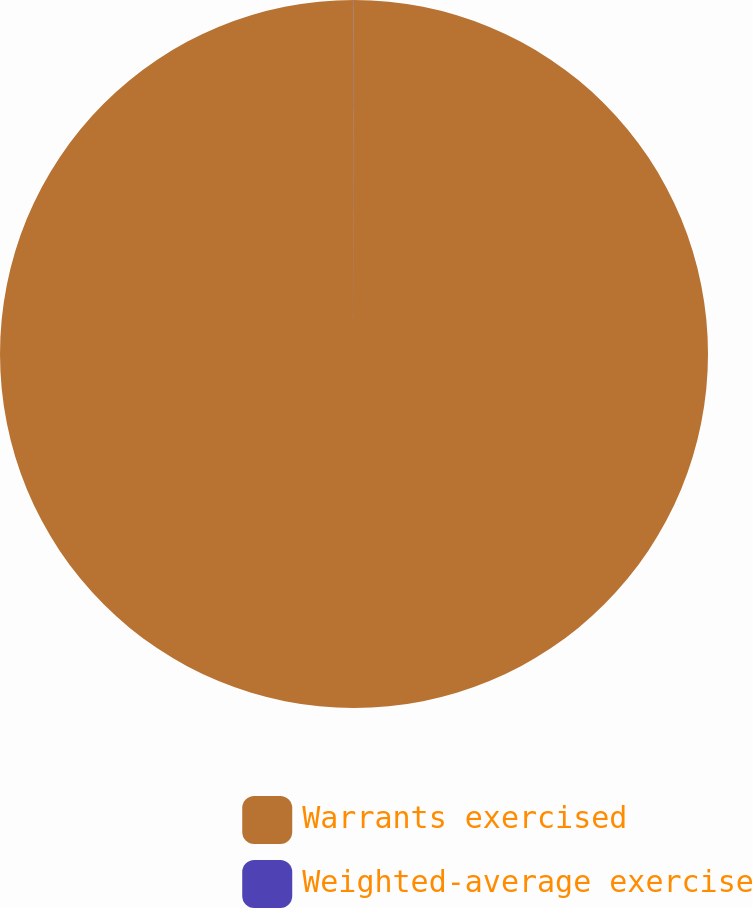Convert chart to OTSL. <chart><loc_0><loc_0><loc_500><loc_500><pie_chart><fcel>Warrants exercised<fcel>Weighted-average exercise<nl><fcel>99.99%<fcel>0.01%<nl></chart> 